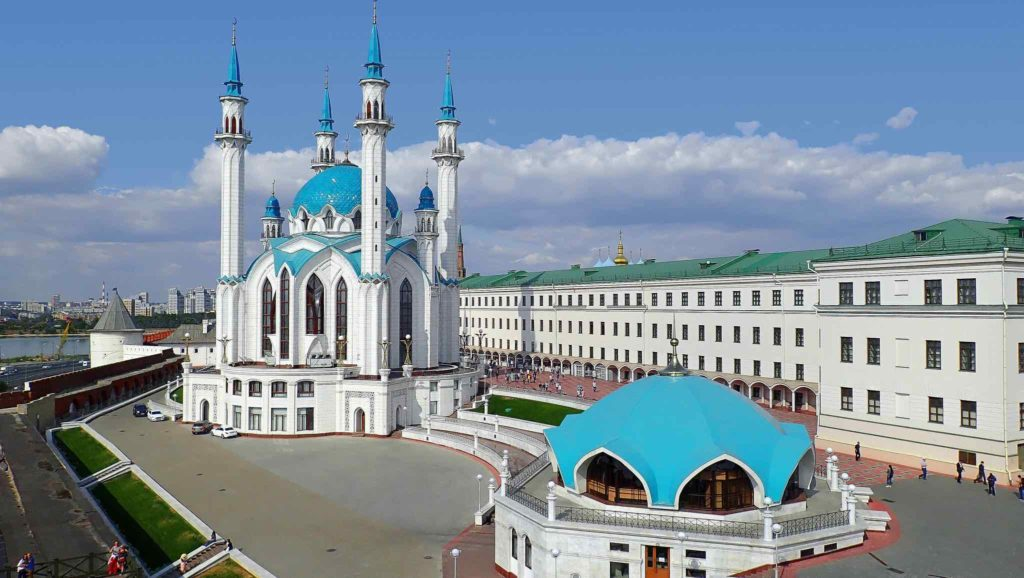Is there a historical event connected to this site? Yes, the Kazan Kremlin is deeply connected to the history of the Tatar people and the city of Kazan. One significant historical event is the Siege of Kazan in 1552, during which the forces of Tsar Ivan the Terrible captured the city and brought an end to the Khanate of Kazan. This event marked a turning point in the region's history, leading to the eventual incorporation of Tatarstan into the Russian state. The Kremlin has since been a symbol of resilience and cultural fusion, representing the rich history and diverse heritage of the Tatar and Russian peoples. 